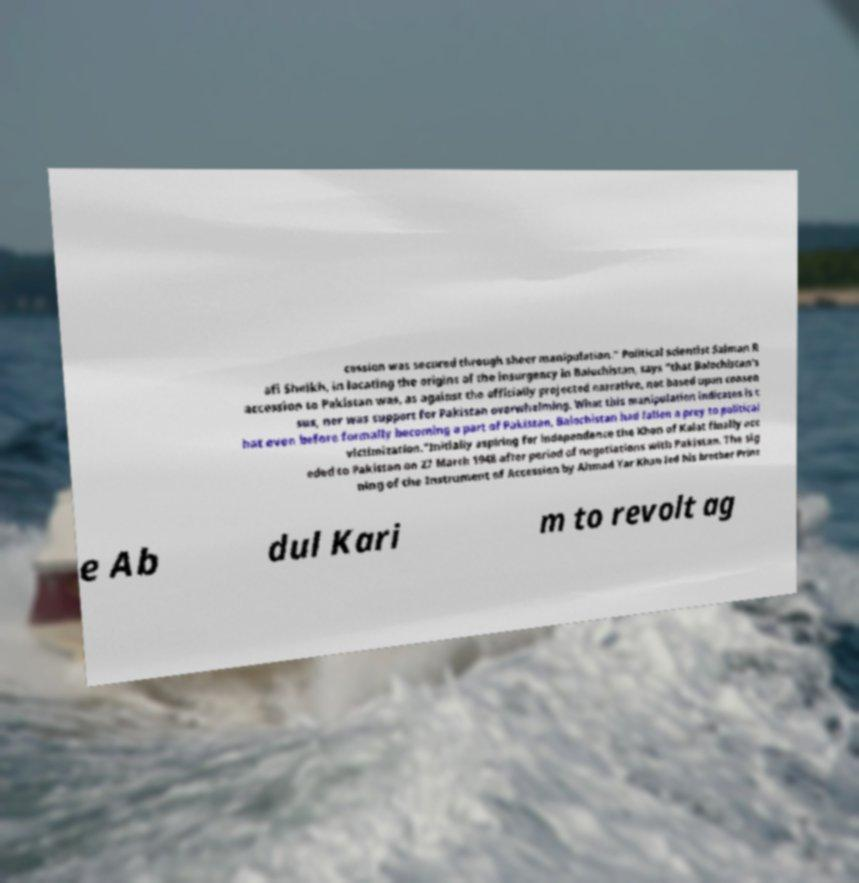Could you assist in decoding the text presented in this image and type it out clearly? cession was secured through sheer manipulation." Political scientist Salman R afi Sheikh, in locating the origins of the insurgency in Balochistan, says "that Balochistan's accession to Pakistan was, as against the officially projected narrative, not based upon consen sus, nor was support for Pakistan overwhelming. What this manipulation indicates is t hat even before formally becoming a part of Pakistan, Balochistan had fallen a prey to political victimization."Initially aspiring for independence the Khan of Kalat finally acc eded to Pakistan on 27 March 1948 after period of negotiations with Pakistan. The sig ning of the Instrument of Accession by Ahmad Yar Khan led his brother Princ e Ab dul Kari m to revolt ag 